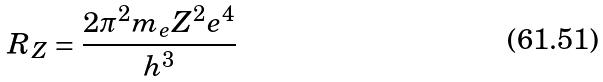<formula> <loc_0><loc_0><loc_500><loc_500>R _ { Z } = \frac { 2 \pi ^ { 2 } m _ { e } Z ^ { 2 } e ^ { 4 } } { h ^ { 3 } }</formula> 